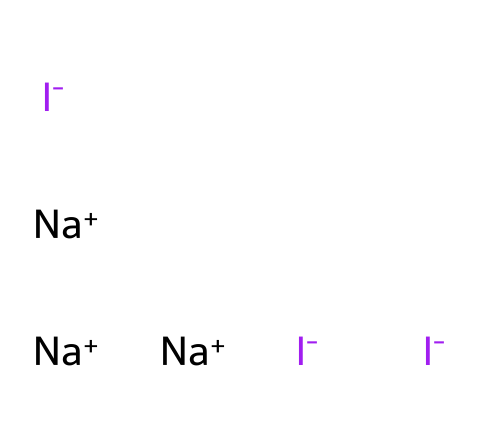What is the molecular formula represented by this SMILES? The SMILES notation contains three iodine atoms, three sodium atoms, and two negative charges. Counting gives us two distinct elements and their respective quantities: Iodine (I) and Sodium (Na). Thus, the molecular formula can be deduced as Na3I3.
Answer: Na3I3 How many iodine atoms are present in this structure? By examining the SMILES notation, we see three instances of iodine represented by 'I-', which indicates there are three iodine atoms in total.
Answer: 3 What type of ions are present in this chemical? The SMILES indicates that the structure contains iodide ions (I-) and sodium ions (Na+). The negative charge is shown for iodine atoms and a positive charge for sodium.
Answer: Iodide and sodium What is the total charge of the compound? There are three iodide ions, each carrying a -1 charge, resulting in a -3 charge overall. There are also three sodium ions contributing +1 charge each, giving a total of +3 charge. Overall, -3 + 3 equals 0, so the total charge of the compound is neutral.
Answer: 0 How does the presence of sodium affect the stability of iodine in this structure? Sodium ions are positively charged and can neutralize the negative charges of the iodide ions. This electrostatic attraction helps stabilize the overall structure by forming ionic bonds between sodium and iodide ions, which leads to improved solubility and efficacy of the disinfectant solution.
Answer: Increases stability What is the primary reason for using iodine in disinfectant solutions? Iodine is widely recognized for its antimicrobial properties. It acts as an effective disinfectant due to its ability to disrupt the cellular structure of pathogens, thereby killing bacteria, viruses, and fungi.
Answer: Antimicrobial properties 